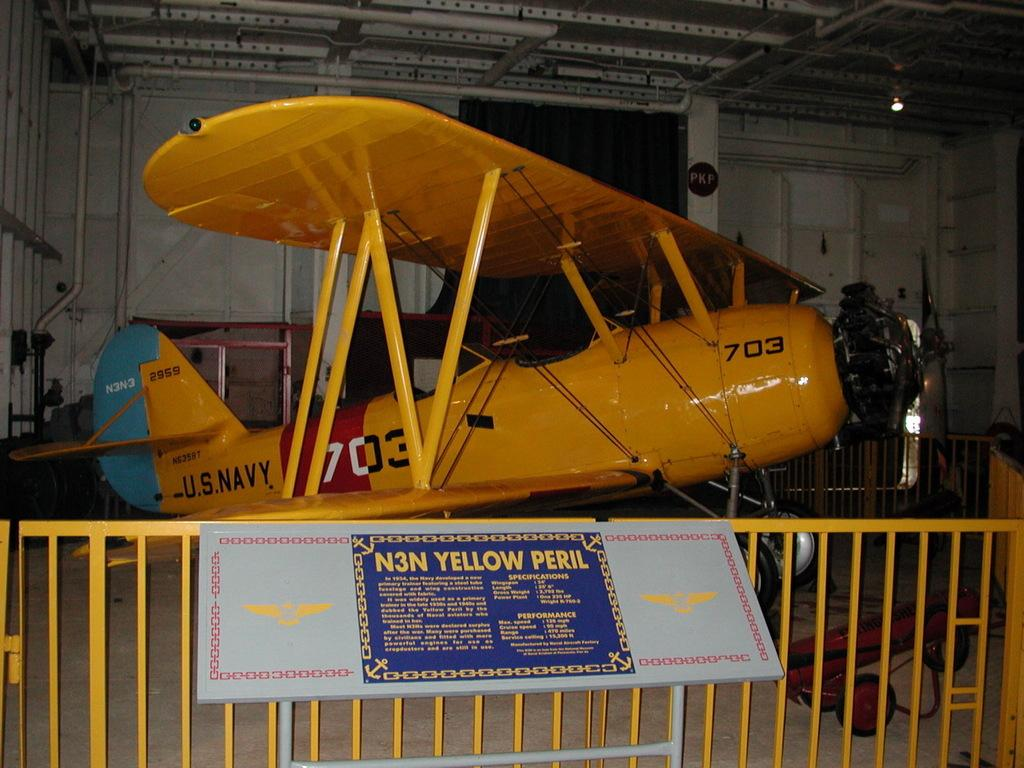<image>
Render a clear and concise summary of the photo. N3N yellow peril out on display that is from the U.S Navy 